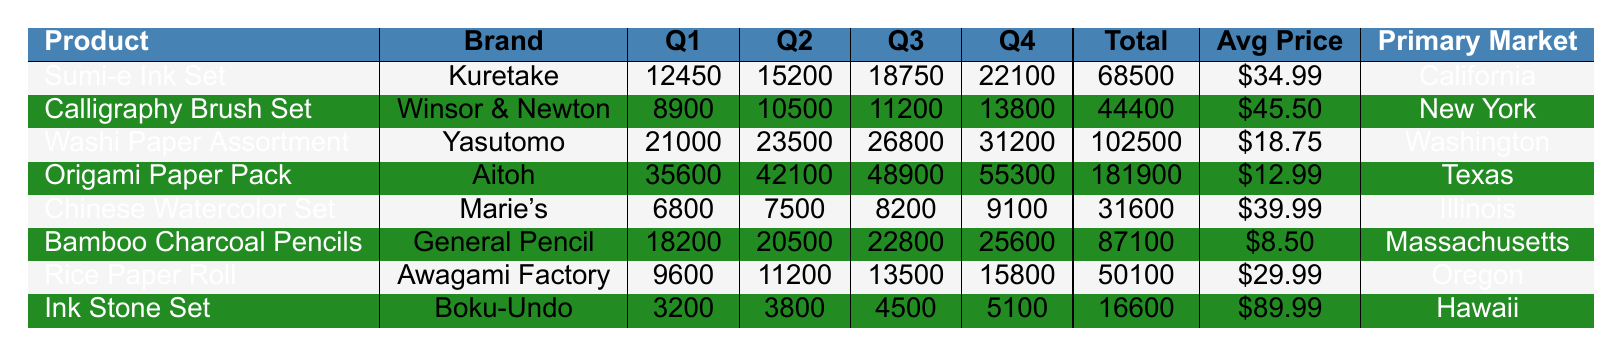What is the total sales of the Washi Paper Assortment? The total sales value for the Washi Paper Assortment can be found directly in the table, which states it is 102500.
Answer: 102500 Which product had the highest Q4 sales? By looking at the Q4 Sales column, the Origami Paper Pack shows the highest value of 55300 compared to other products in that quarter.
Answer: Origami Paper Pack What is the average sales for the Chinese Watercolor Set across all quarters? To find the average, add the sales from all quarters (6800 + 7500 + 8200 + 9100 = 31600) and divide by 4, resulting in 31600/4 = 7900.
Answer: 7900 Did the Bamboo Charcoal Pencils reach a total sales of over 80000? The total sales for Bamboo Charcoal Pencils is listed at 87100, which is indeed over 80000.
Answer: Yes What was the difference in total sales between the Sumi-e Ink Set and the Calligraphy Brush Set? The Sumi-e Ink Set's total sales are 68500 and the Calligraphy Brush Set's total sales are 44400. The difference is 68500 - 44400 = 24100.
Answer: 24100 Which primary market had the highest sales of Origami Paper Pack? The Origami Paper Pack had its highest sales in Texas, as indicated in the Primary Market column.
Answer: Texas What is the total sales for oak-based products if the Bamboo Charcoal Pencils and the Ink Stone Set are categorized together? Adding the total sales for both products: Bamboo Charcoal Pencils total sales is 87100 and Ink Stone Set total sales is 16600. The sum gives 87100 + 16600 = 103700.
Answer: 103700 Which product had the lowest average price? The average price can be compared across all products, and the Bamboo Charcoal Pencils have the lowest average price listed at 8.50.
Answer: Bamboo Charcoal Pencils What is the total sales of all products combined? Adding the total sales of all products: 68500 (Sumi-e) + 44400 (Calligraphy) + 102500 (Washi) + 181900 (Origami) + 31600 (Chinese) + 87100 (Bamboo) + 50100 (Rice) + 16600 (Ink Stone) totals to 437700.
Answer: 437700 Which product had the highest average sales across the four quarters? The average can be calculated by dividing the total sales of each product by four. The Origami Paper Pack has the highest total sales (181900), hence its average (181900/4 = 45475) is the highest.
Answer: Origami Paper Pack 